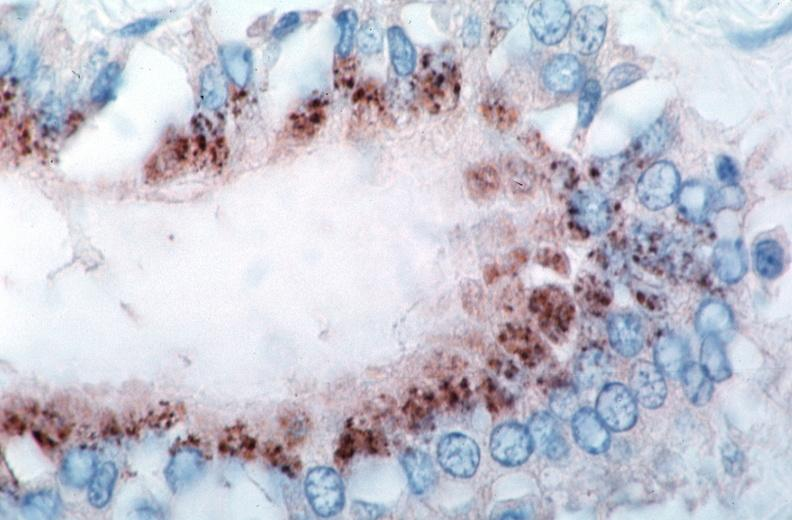what does this image show?
Answer the question using a single word or phrase. Vasculitis 